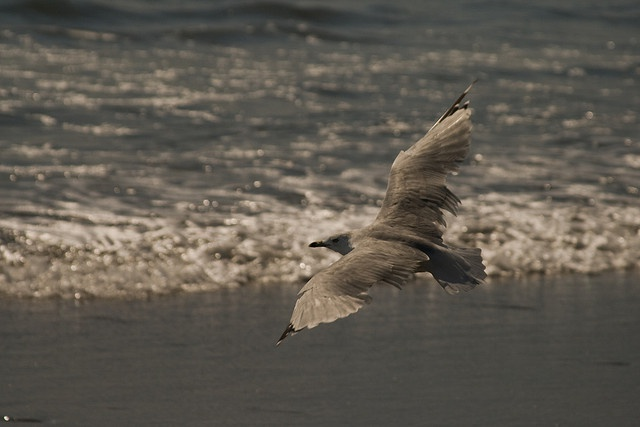Describe the objects in this image and their specific colors. I can see a bird in black and gray tones in this image. 